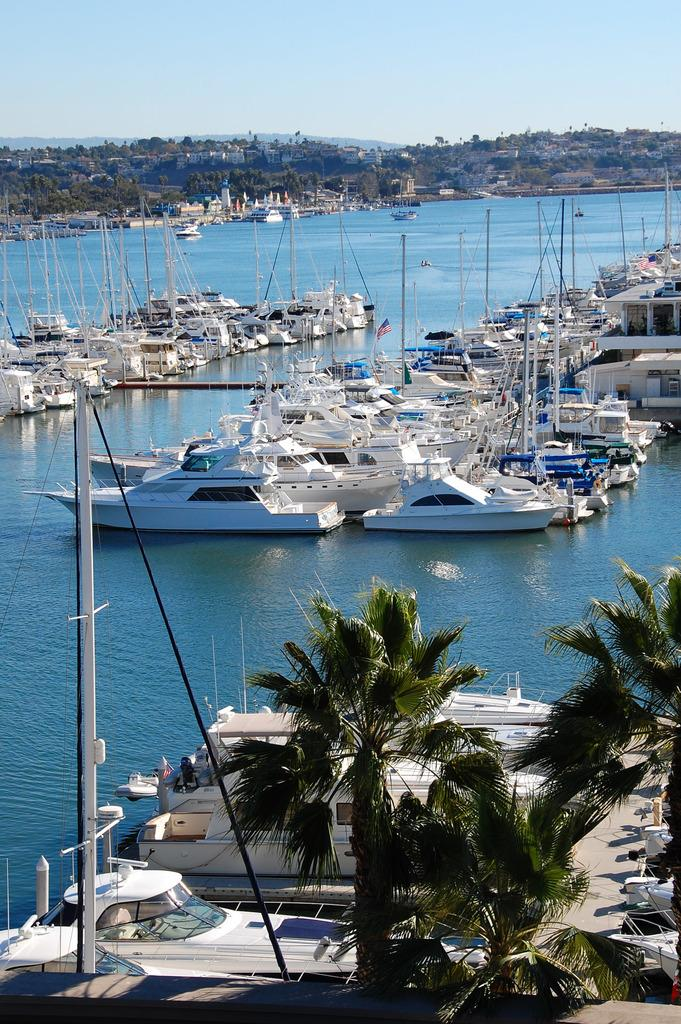What is on the water in the image? There are boats on the water in the image. What type of structures can be seen in the image? There are houses in the image. What type of vegetation is present in the image? There are trees in the image. What else can be seen in the image besides the boats, houses, and trees? There are some objects in the image. What is visible in the background of the image? The sky is visible in the background of the image. What type of rice is being cooked in the vessel in the image? There is no vessel or rice present in the image. What type of table is visible in the image? There is no table present in the image. 